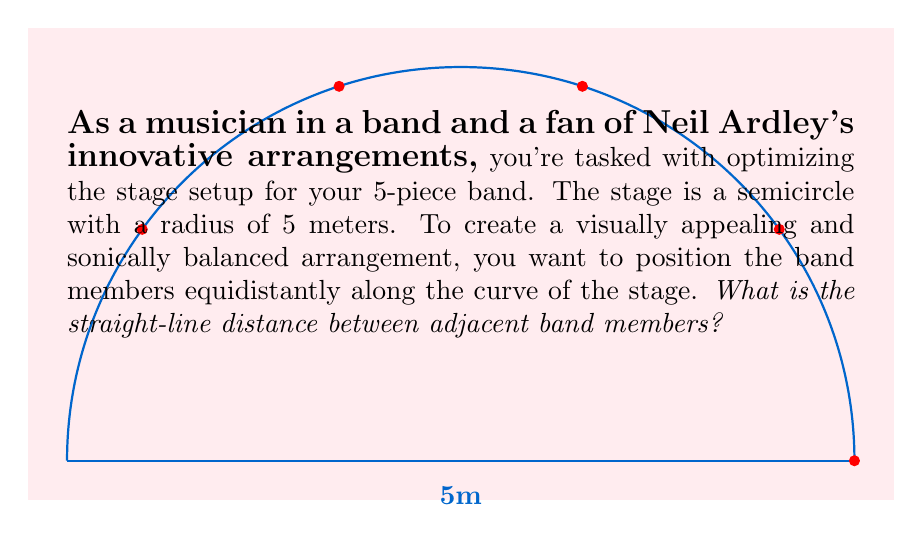Solve this math problem. Let's approach this step-by-step:

1) The stage is a semicircle, which has an angle of 180°.

2) With 5 band members, we need to divide the 180° evenly into 4 equal parts (as the first and last members will be at the ends of the semicircle). So, the angle between each member is:

   $$\theta = \frac{180°}{4} = 45°$$

3) Now, we can use the chord formula to find the straight-line distance between adjacent members. The chord length $d$ for a circle with radius $r$ and central angle $\theta$ (in radians) is:

   $$d = 2r \sin(\frac{\theta}{2})$$

4) We need to convert 45° to radians:

   $$45° \times \frac{\pi}{180°} = \frac{\pi}{4} \text{ radians}$$

5) Now we can plug these values into our formula:

   $$d = 2 \times 5 \times \sin(\frac{\pi}{8})$$

6) Simplifying:

   $$d = 10 \sin(\frac{\pi}{8}) \approx 3.8268 \text{ meters}$$

Therefore, the straight-line distance between adjacent band members is approximately 3.83 meters.
Answer: $10 \sin(\frac{\pi}{8}) \approx 3.83$ meters 